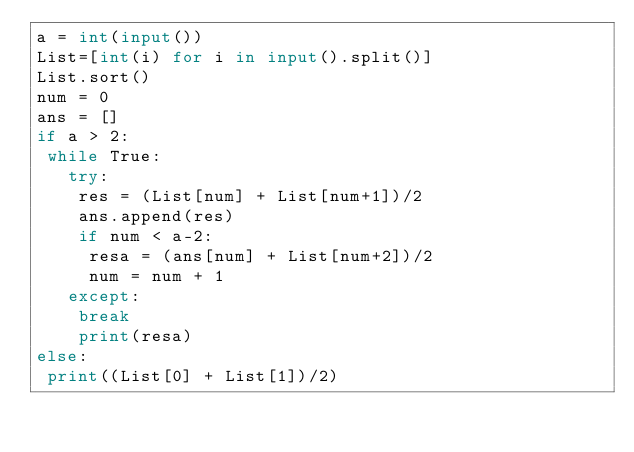<code> <loc_0><loc_0><loc_500><loc_500><_Python_>a = int(input())
List=[int(i) for i in input().split()]
List.sort()
num = 0
ans = []
if a > 2:
 while True:
   try:
    res = (List[num] + List[num+1])/2
    ans.append(res)
    if num < a-2:
     resa = (ans[num] + List[num+2])/2
     num = num + 1
   except:
    break
    print(resa)
else:
 print((List[0] + List[1])/2)
</code> 